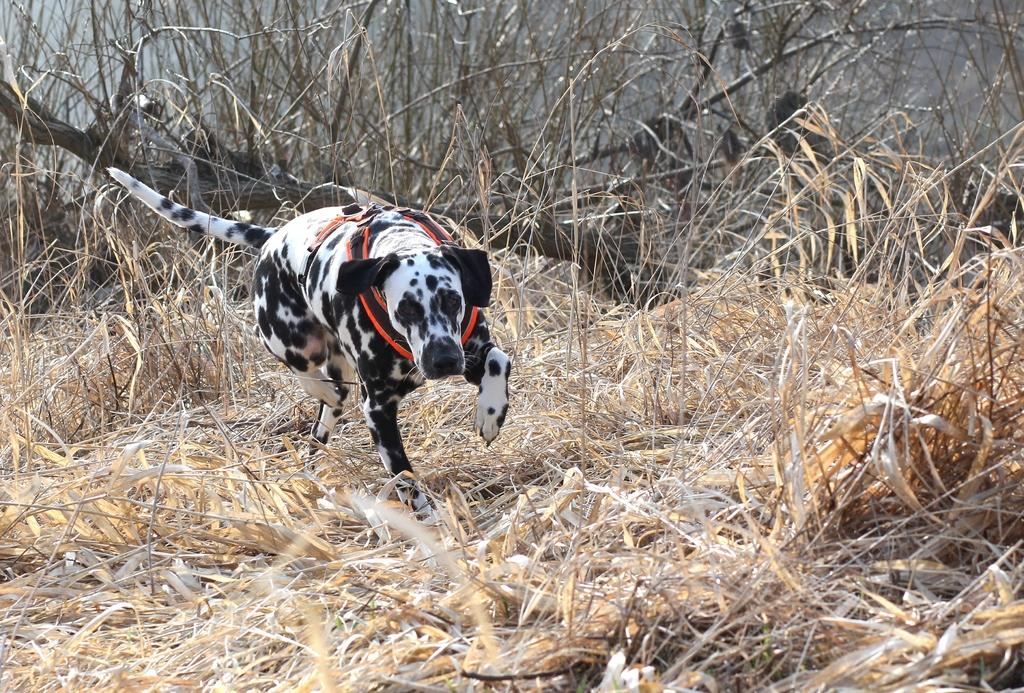What type of animal is in the image? There is a dalmatian dog in the image. What is the dog doing in the image? The dog is walking on dry grassland. What type of sweater is the dog wearing in the image? There is no sweater present in the image; the dog is not wearing any clothing. 